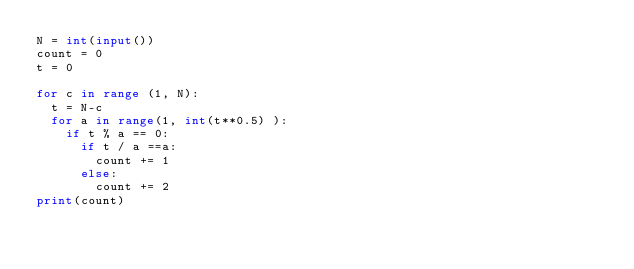<code> <loc_0><loc_0><loc_500><loc_500><_Python_>N = int(input())
count = 0
t = 0

for c in range (1, N):
  t = N-c
  for a in range(1, int(t**0.5) ):
    if t % a == 0:
      if t / a ==a:
        count += 1
      else:
        count += 2
print(count)
</code> 